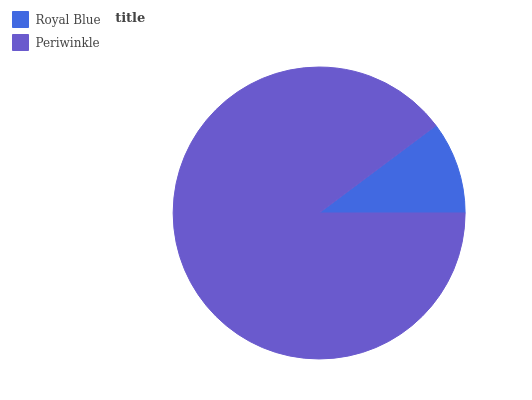Is Royal Blue the minimum?
Answer yes or no. Yes. Is Periwinkle the maximum?
Answer yes or no. Yes. Is Periwinkle the minimum?
Answer yes or no. No. Is Periwinkle greater than Royal Blue?
Answer yes or no. Yes. Is Royal Blue less than Periwinkle?
Answer yes or no. Yes. Is Royal Blue greater than Periwinkle?
Answer yes or no. No. Is Periwinkle less than Royal Blue?
Answer yes or no. No. Is Periwinkle the high median?
Answer yes or no. Yes. Is Royal Blue the low median?
Answer yes or no. Yes. Is Royal Blue the high median?
Answer yes or no. No. Is Periwinkle the low median?
Answer yes or no. No. 